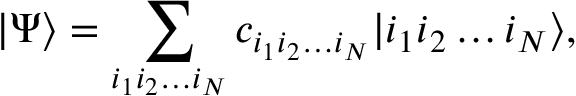Convert formula to latex. <formula><loc_0><loc_0><loc_500><loc_500>\left | \Psi \right \rangle = \sum _ { i _ { 1 } i _ { 2 } \dots i _ { N } } { c _ { i _ { 1 } i _ { 2 } \dots i _ { N } } | i _ { 1 } i _ { 2 } \dots i _ { N } \rangle } ,</formula> 